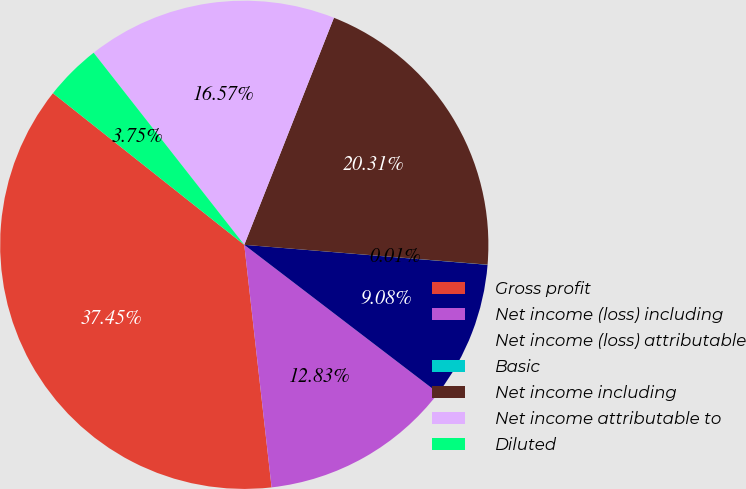Convert chart to OTSL. <chart><loc_0><loc_0><loc_500><loc_500><pie_chart><fcel>Gross profit<fcel>Net income (loss) including<fcel>Net income (loss) attributable<fcel>Basic<fcel>Net income including<fcel>Net income attributable to<fcel>Diluted<nl><fcel>37.45%<fcel>12.83%<fcel>9.08%<fcel>0.01%<fcel>20.31%<fcel>16.57%<fcel>3.75%<nl></chart> 